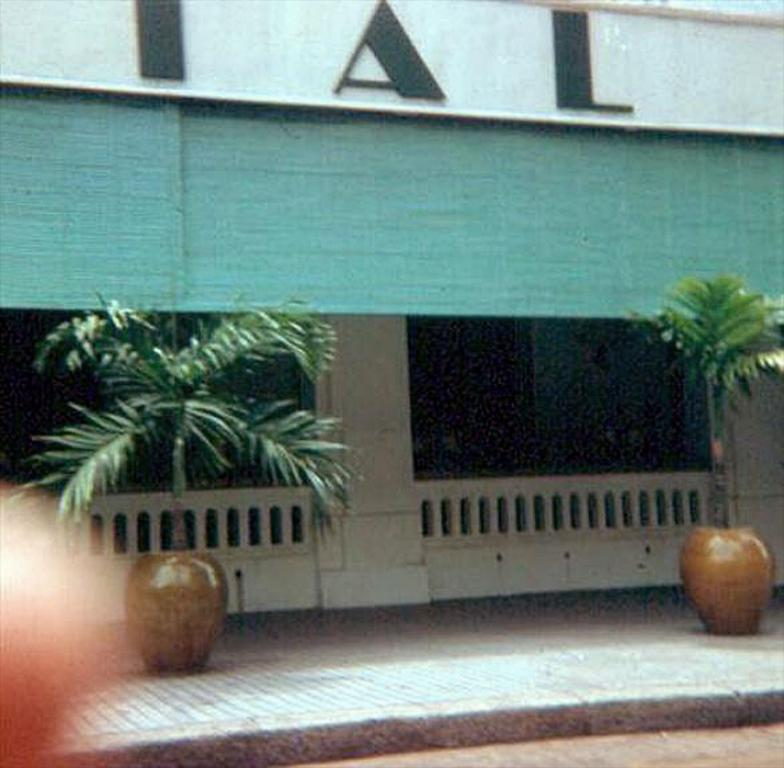What can be seen on the ground in the image? There are plant pots on the ground in the image. What is visible in the background of the image? There is a fence and a wall with writing in the background of the image. What color is the object in the background of the image? There is a green color object in the background of the image. How does the family interact with the plant pots in the image? There is no family present in the image, only plant pots on the ground. What type of crush is depicted in the image? There is no crush depicted in the image; it features plant pots, a fence, a wall with writing, and a green object. 